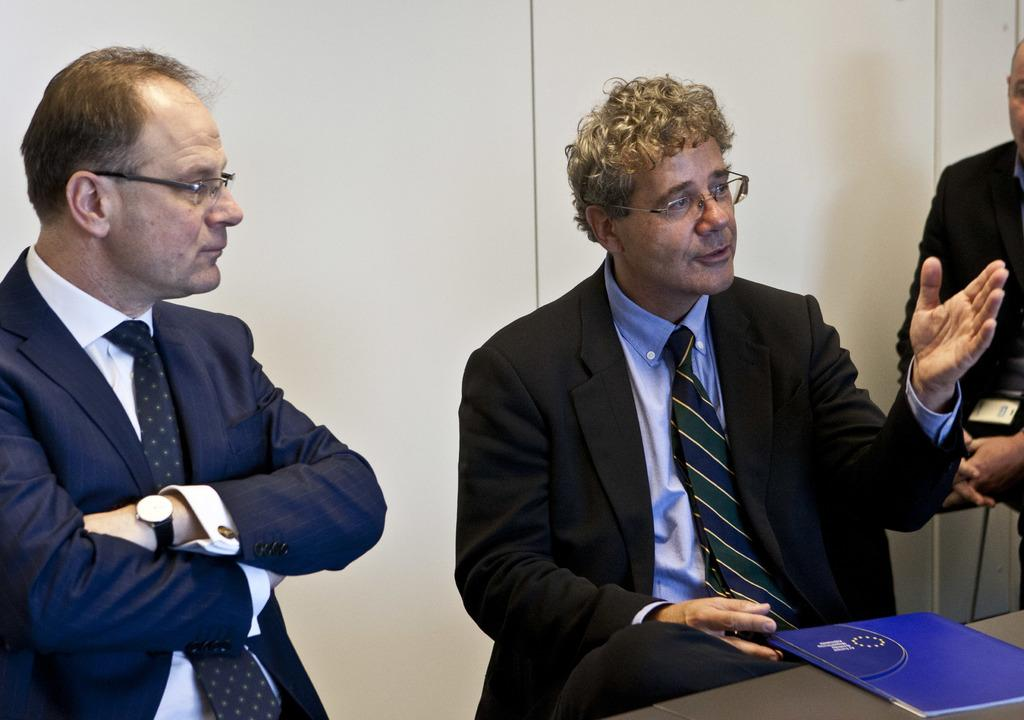What are the people in the image doing? The persons in the image are sitting on chairs. How are the chairs arranged in the image? The chairs are positioned around a table. What object can be seen on the table? There is a book on the table. What can be seen in the background of the image? There is a wall in the background of the image. Can you see any branches or cables hanging from the ceiling in the image? No, there are no branches or cables visible in the image. Did an earthquake occur in the image? There is no indication of an earthquake in the image. 